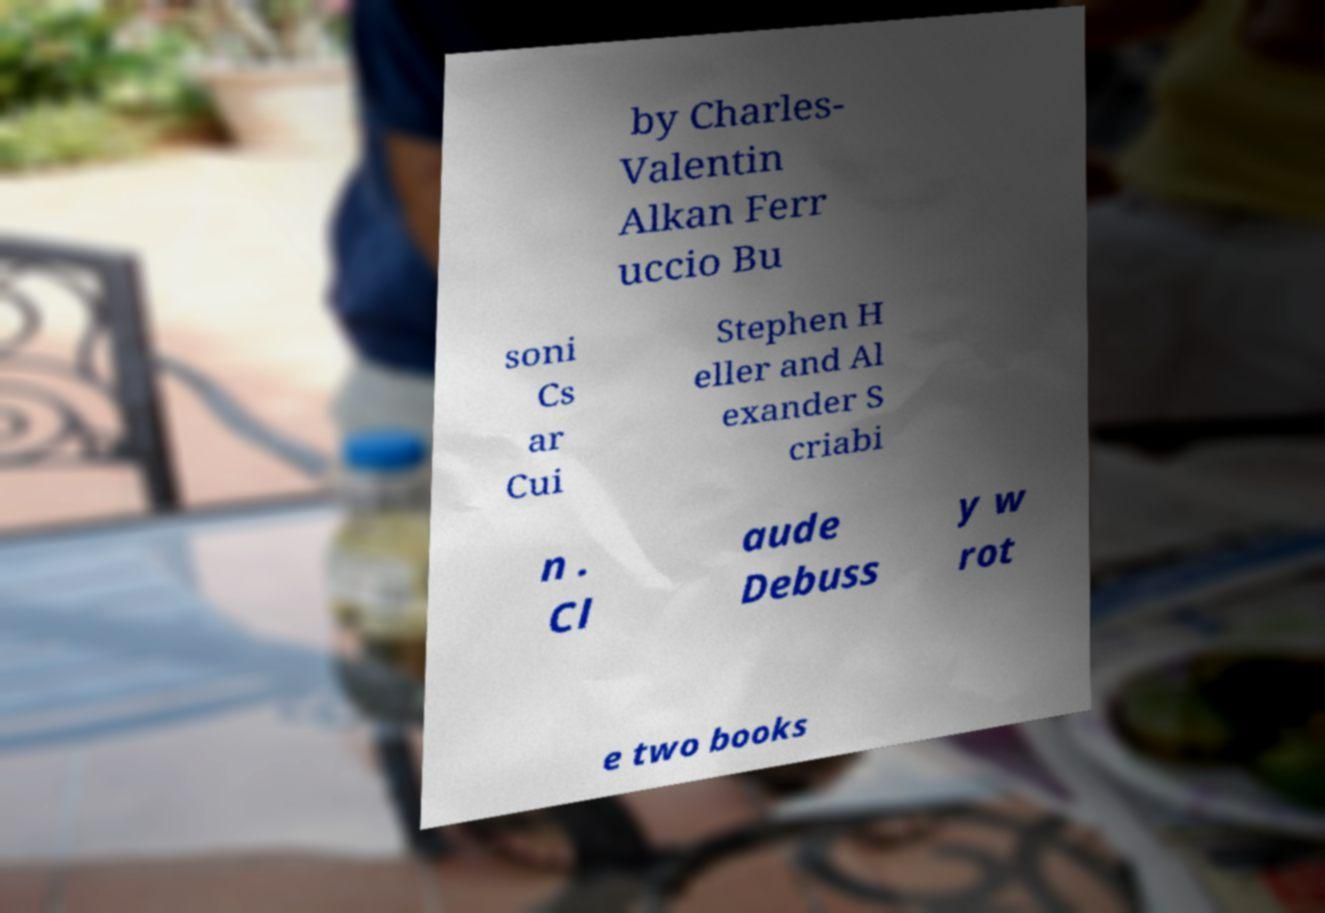Please read and relay the text visible in this image. What does it say? by Charles- Valentin Alkan Ferr uccio Bu soni Cs ar Cui Stephen H eller and Al exander S criabi n . Cl aude Debuss y w rot e two books 